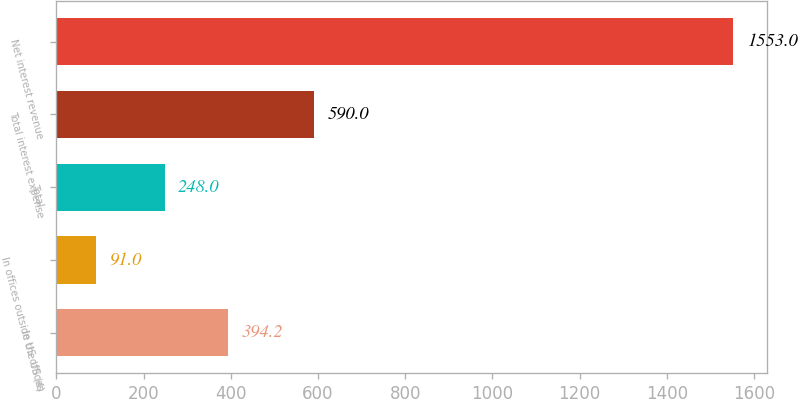Convert chart to OTSL. <chart><loc_0><loc_0><loc_500><loc_500><bar_chart><fcel>In US offices<fcel>In offices outside the US (4)<fcel>Total<fcel>Total interest expense<fcel>Net interest revenue<nl><fcel>394.2<fcel>91<fcel>248<fcel>590<fcel>1553<nl></chart> 